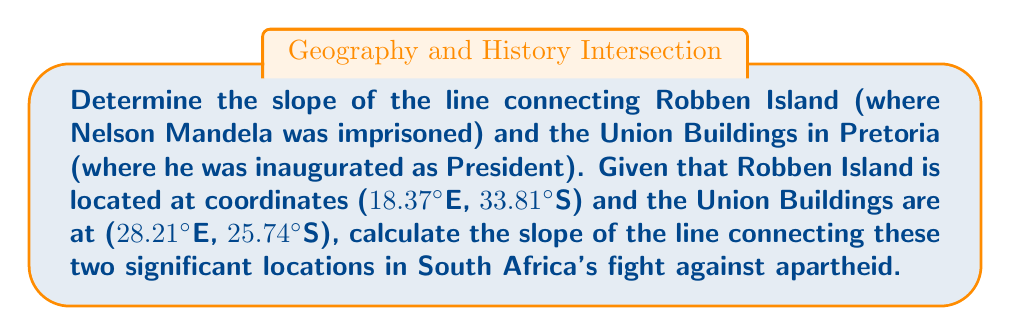Help me with this question. To find the slope of the line connecting two points, we use the slope formula:

$$ m = \frac{y_2 - y_1}{x_2 - x_1} $$

Where $(x_1, y_1)$ is the first point and $(x_2, y_2)$ is the second point.

1. Identify the coordinates:
   - Robben Island: $(x_1, y_1) = (18.37, -33.81)$
   - Union Buildings: $(x_2, y_2) = (28.21, -25.74)$

   Note: We use negative values for South latitude.

2. Substitute these values into the slope formula:

   $$ m = \frac{-25.74 - (-33.81)}{28.21 - 18.37} $$

3. Simplify the numerator:
   $$ m = \frac{-25.74 + 33.81}{28.21 - 18.37} = \frac{8.07}{9.84} $$

4. Divide to get the final slope:
   $$ m = 0.8201219512195122 $$

This positive slope indicates that as we move from Robben Island to the Union Buildings, we're moving northeast, symbolizing Mandela's journey from imprisonment to presidency.
Answer: $0.8201$ 